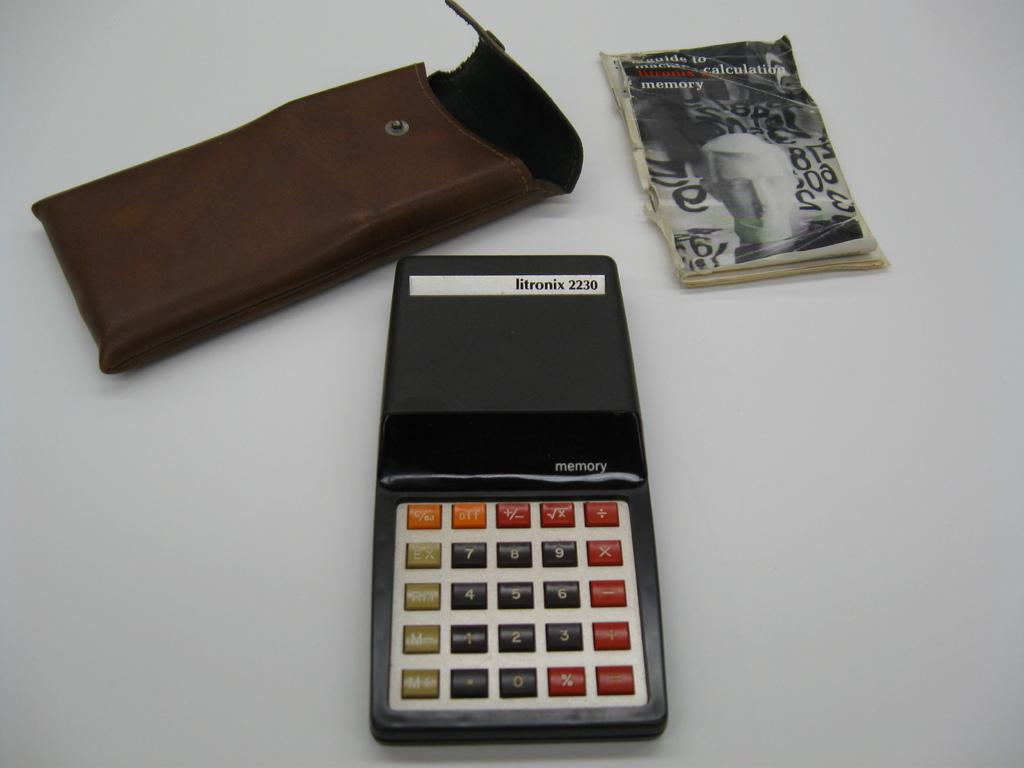<image>
Write a terse but informative summary of the picture. A Litronix 2230 branded calculator sitting next to its sleeve. 